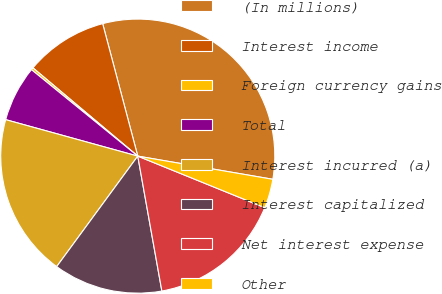<chart> <loc_0><loc_0><loc_500><loc_500><pie_chart><fcel>(In millions)<fcel>Interest income<fcel>Foreign currency gains<fcel>Total<fcel>Interest incurred (a)<fcel>Interest capitalized<fcel>Net interest expense<fcel>Other<nl><fcel>31.83%<fcel>9.74%<fcel>0.27%<fcel>6.58%<fcel>19.21%<fcel>12.89%<fcel>16.05%<fcel>3.43%<nl></chart> 